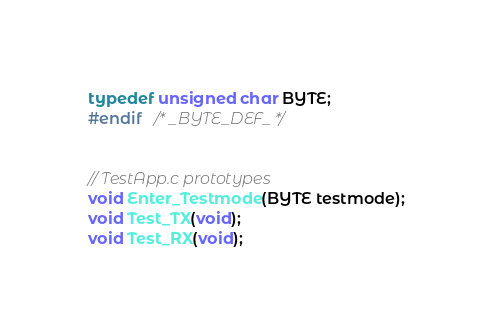Convert code to text. <code><loc_0><loc_0><loc_500><loc_500><_C_>typedef unsigned char BYTE;
#endif   /* _BYTE_DEF_ */


// TestApp.c prototypes
void Enter_Testmode(BYTE testmode);
void Test_TX(void);
void Test_RX(void);
</code> 